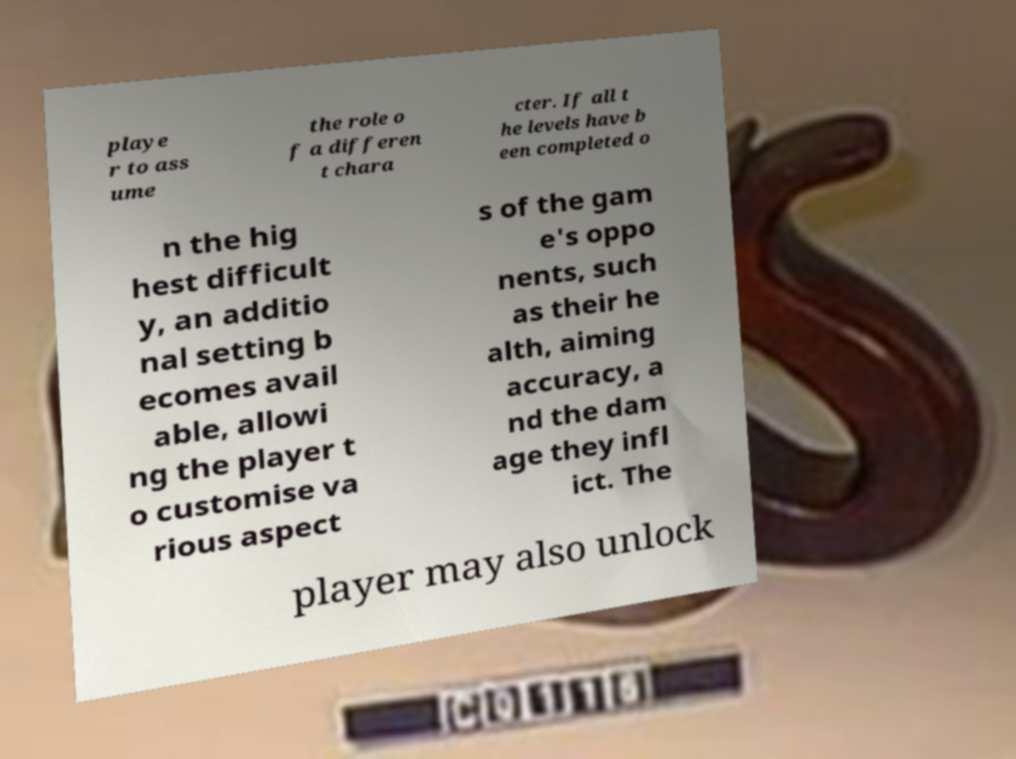Could you assist in decoding the text presented in this image and type it out clearly? playe r to ass ume the role o f a differen t chara cter. If all t he levels have b een completed o n the hig hest difficult y, an additio nal setting b ecomes avail able, allowi ng the player t o customise va rious aspect s of the gam e's oppo nents, such as their he alth, aiming accuracy, a nd the dam age they infl ict. The player may also unlock 